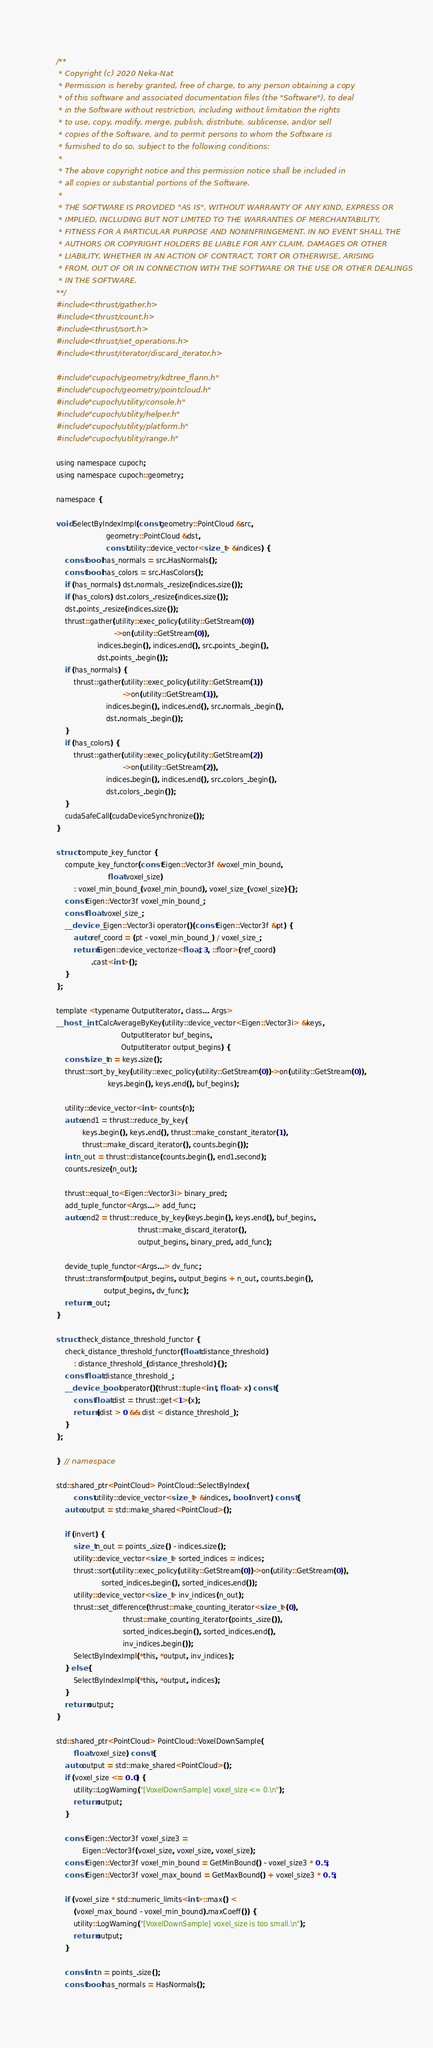Convert code to text. <code><loc_0><loc_0><loc_500><loc_500><_Cuda_>/**
 * Copyright (c) 2020 Neka-Nat
 * Permission is hereby granted, free of charge, to any person obtaining a copy
 * of this software and associated documentation files (the "Software"), to deal
 * in the Software without restriction, including without limitation the rights
 * to use, copy, modify, merge, publish, distribute, sublicense, and/or sell
 * copies of the Software, and to permit persons to whom the Software is
 * furnished to do so, subject to the following conditions:
 * 
 * The above copyright notice and this permission notice shall be included in
 * all copies or substantial portions of the Software.
 * 
 * THE SOFTWARE IS PROVIDED "AS IS", WITHOUT WARRANTY OF ANY KIND, EXPRESS OR
 * IMPLIED, INCLUDING BUT NOT LIMITED TO THE WARRANTIES OF MERCHANTABILITY,
 * FITNESS FOR A PARTICULAR PURPOSE AND NONINFRINGEMENT. IN NO EVENT SHALL THE
 * AUTHORS OR COPYRIGHT HOLDERS BE LIABLE FOR ANY CLAIM, DAMAGES OR OTHER
 * LIABILITY, WHETHER IN AN ACTION OF CONTRACT, TORT OR OTHERWISE, ARISING
 * FROM, OUT OF OR IN CONNECTION WITH THE SOFTWARE OR THE USE OR OTHER DEALINGS
 * IN THE SOFTWARE.
**/
#include <thrust/gather.h>
#include <thrust/count.h>
#include <thrust/sort.h>
#include <thrust/set_operations.h>
#include <thrust/iterator/discard_iterator.h>

#include "cupoch/geometry/kdtree_flann.h"
#include "cupoch/geometry/pointcloud.h"
#include "cupoch/utility/console.h"
#include "cupoch/utility/helper.h"
#include "cupoch/utility/platform.h"
#include "cupoch/utility/range.h"

using namespace cupoch;
using namespace cupoch::geometry;

namespace {

void SelectByIndexImpl(const geometry::PointCloud &src,
                       geometry::PointCloud &dst,
                       const utility::device_vector<size_t> &indices) {
    const bool has_normals = src.HasNormals();
    const bool has_colors = src.HasColors();
    if (has_normals) dst.normals_.resize(indices.size());
    if (has_colors) dst.colors_.resize(indices.size());
    dst.points_.resize(indices.size());
    thrust::gather(utility::exec_policy(utility::GetStream(0))
                           ->on(utility::GetStream(0)),
                   indices.begin(), indices.end(), src.points_.begin(),
                   dst.points_.begin());
    if (has_normals) {
        thrust::gather(utility::exec_policy(utility::GetStream(1))
                               ->on(utility::GetStream(1)),
                       indices.begin(), indices.end(), src.normals_.begin(),
                       dst.normals_.begin());
    }
    if (has_colors) {
        thrust::gather(utility::exec_policy(utility::GetStream(2))
                               ->on(utility::GetStream(2)),
                       indices.begin(), indices.end(), src.colors_.begin(),
                       dst.colors_.begin());
    }
    cudaSafeCall(cudaDeviceSynchronize());
}

struct compute_key_functor {
    compute_key_functor(const Eigen::Vector3f &voxel_min_bound,
                        float voxel_size)
        : voxel_min_bound_(voxel_min_bound), voxel_size_(voxel_size){};
    const Eigen::Vector3f voxel_min_bound_;
    const float voxel_size_;
    __device__ Eigen::Vector3i operator()(const Eigen::Vector3f &pt) {
        auto ref_coord = (pt - voxel_min_bound_) / voxel_size_;
        return Eigen::device_vectorize<float, 3, ::floor>(ref_coord)
                .cast<int>();
    }
};

template <typename OutputIterator, class... Args>
__host__ int CalcAverageByKey(utility::device_vector<Eigen::Vector3i> &keys,
                              OutputIterator buf_begins,
                              OutputIterator output_begins) {
    const size_t n = keys.size();
    thrust::sort_by_key(utility::exec_policy(utility::GetStream(0))->on(utility::GetStream(0)),
                        keys.begin(), keys.end(), buf_begins);

    utility::device_vector<int> counts(n);
    auto end1 = thrust::reduce_by_key(
            keys.begin(), keys.end(), thrust::make_constant_iterator(1),
            thrust::make_discard_iterator(), counts.begin());
    int n_out = thrust::distance(counts.begin(), end1.second);
    counts.resize(n_out);

    thrust::equal_to<Eigen::Vector3i> binary_pred;
    add_tuple_functor<Args...> add_func;
    auto end2 = thrust::reduce_by_key(keys.begin(), keys.end(), buf_begins,
                                      thrust::make_discard_iterator(),
                                      output_begins, binary_pred, add_func);

    devide_tuple_functor<Args...> dv_func;
    thrust::transform(output_begins, output_begins + n_out, counts.begin(),
                      output_begins, dv_func);
    return n_out;
}

struct check_distance_threshold_functor {
    check_distance_threshold_functor(float distance_threshold)
        : distance_threshold_(distance_threshold){};
    const float distance_threshold_;
    __device__ bool operator()(thrust::tuple<int, float> x) const {
        const float dist = thrust::get<1>(x);
        return (dist > 0 && dist < distance_threshold_);
    }
};

}  // namespace

std::shared_ptr<PointCloud> PointCloud::SelectByIndex(
        const utility::device_vector<size_t> &indices, bool invert) const {
    auto output = std::make_shared<PointCloud>();

    if (invert) {
        size_t n_out = points_.size() - indices.size();
        utility::device_vector<size_t> sorted_indices = indices;
        thrust::sort(utility::exec_policy(utility::GetStream(0))->on(utility::GetStream(0)),
                     sorted_indices.begin(), sorted_indices.end());
        utility::device_vector<size_t> inv_indices(n_out);
        thrust::set_difference(thrust::make_counting_iterator<size_t>(0),
                               thrust::make_counting_iterator(points_.size()),
                               sorted_indices.begin(), sorted_indices.end(),
                               inv_indices.begin());
        SelectByIndexImpl(*this, *output, inv_indices);
    } else {
        SelectByIndexImpl(*this, *output, indices);
    }
    return output;
}

std::shared_ptr<PointCloud> PointCloud::VoxelDownSample(
        float voxel_size) const {
    auto output = std::make_shared<PointCloud>();
    if (voxel_size <= 0.0) {
        utility::LogWarning("[VoxelDownSample] voxel_size <= 0.\n");
        return output;
    }

    const Eigen::Vector3f voxel_size3 =
            Eigen::Vector3f(voxel_size, voxel_size, voxel_size);
    const Eigen::Vector3f voxel_min_bound = GetMinBound() - voxel_size3 * 0.5;
    const Eigen::Vector3f voxel_max_bound = GetMaxBound() + voxel_size3 * 0.5;

    if (voxel_size * std::numeric_limits<int>::max() <
        (voxel_max_bound - voxel_min_bound).maxCoeff()) {
        utility::LogWarning("[VoxelDownSample] voxel_size is too small.\n");
        return output;
    }

    const int n = points_.size();
    const bool has_normals = HasNormals();</code> 